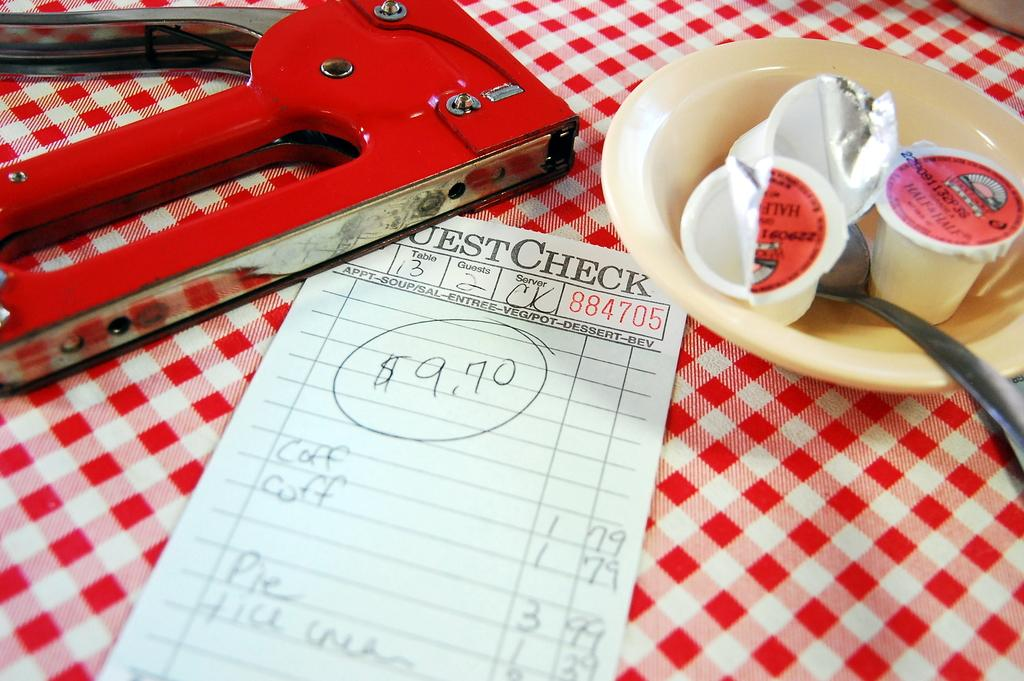<image>
Provide a brief description of the given image. the check on the dining table is for 9.70 